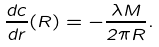<formula> <loc_0><loc_0><loc_500><loc_500>\frac { d c } { d r } ( R ) = - \frac { \lambda M } { 2 \pi R } .</formula> 